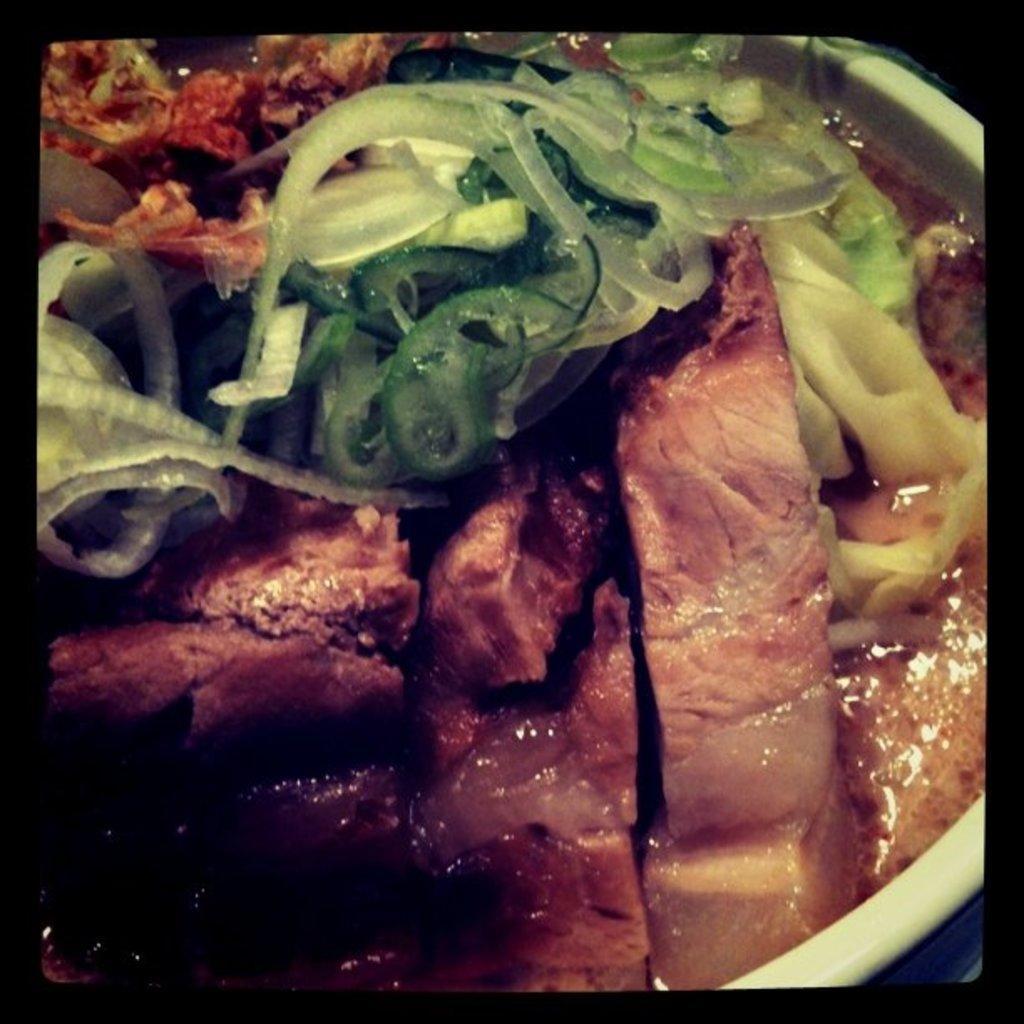Can you describe this image briefly? In this image there is a bowl with mat slices and vegetables in it. 